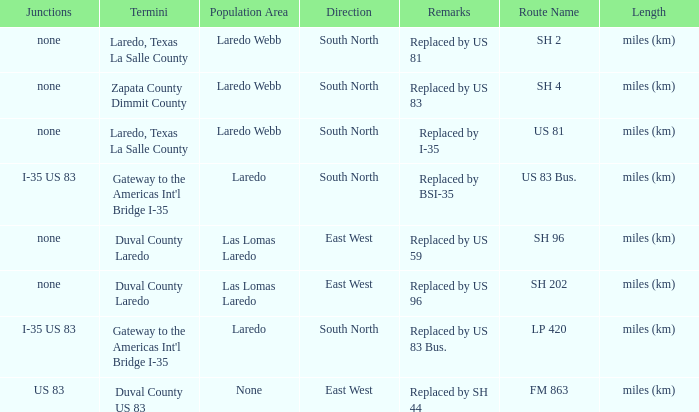Could you help me parse every detail presented in this table? {'header': ['Junctions', 'Termini', 'Population Area', 'Direction', 'Remarks', 'Route Name', 'Length'], 'rows': [['none', 'Laredo, Texas La Salle County', 'Laredo Webb', 'South North', 'Replaced by US 81', 'SH 2', 'miles (km)'], ['none', 'Zapata County Dimmit County', 'Laredo Webb', 'South North', 'Replaced by US 83', 'SH 4', 'miles (km)'], ['none', 'Laredo, Texas La Salle County', 'Laredo Webb', 'South North', 'Replaced by I-35', 'US 81', 'miles (km)'], ['I-35 US 83', "Gateway to the Americas Int'l Bridge I-35", 'Laredo', 'South North', 'Replaced by BSI-35', 'US 83 Bus.', 'miles (km)'], ['none', 'Duval County Laredo', 'Las Lomas Laredo', 'East West', 'Replaced by US 59', 'SH 96', 'miles (km)'], ['none', 'Duval County Laredo', 'Las Lomas Laredo', 'East West', 'Replaced by US 96', 'SH 202', 'miles (km)'], ['I-35 US 83', "Gateway to the Americas Int'l Bridge I-35", 'Laredo', 'South North', 'Replaced by US 83 Bus.', 'LP 420', 'miles (km)'], ['US 83', 'Duval County US 83', 'None', 'East West', 'Replaced by SH 44', 'FM 863', 'miles (km)']]} Which routes have  "replaced by US 81" listed in their remarks section? SH 2. 